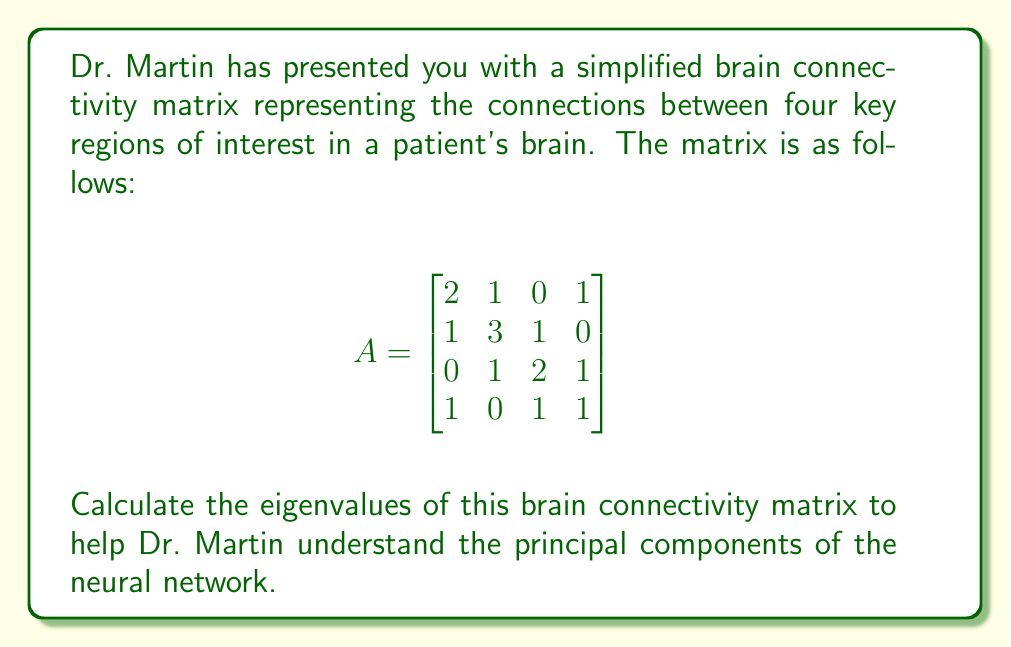What is the answer to this math problem? To find the eigenvalues of the matrix A, we need to solve the characteristic equation:

$$det(A - \lambda I) = 0$$

where $\lambda$ represents the eigenvalues and $I$ is the 4x4 identity matrix.

Step 1: Construct $(A - \lambda I)$
$$(A - \lambda I) = \begin{bmatrix}
2-\lambda & 1 & 0 & 1 \\
1 & 3-\lambda & 1 & 0 \\
0 & 1 & 2-\lambda & 1 \\
1 & 0 & 1 & 1-\lambda
\end{bmatrix}$$

Step 2: Calculate the determinant
$$det(A - \lambda I) = (2-\lambda)(3-\lambda)(2-\lambda)(1-\lambda) - (2-\lambda)(3-\lambda) - (2-\lambda)(1-\lambda) - (1-\lambda)$$

Step 3: Expand and simplify
$$\lambda^4 - 8\lambda^3 + 19\lambda^2 - 16\lambda + 4 = 0$$

Step 4: Solve the characteristic equation
This is a fourth-degree polynomial equation. While it's possible to solve it analytically using methods like Ferrari's solution, in practice, we often use numerical methods or computer algebra systems for higher-degree polynomials.

Using a numerical method, we find the roots of this polynomial:

$$\lambda_1 \approx 4.2915$$
$$\lambda_2 \approx 2.2728$$
$$\lambda_3 \approx 1.0000$$
$$\lambda_4 \approx 0.4357$$

These are the eigenvalues of the brain connectivity matrix.
Answer: The eigenvalues of the brain connectivity matrix are approximately:
$$\lambda_1 \approx 4.2915$$
$$\lambda_2 \approx 2.2728$$
$$\lambda_3 = 1.0000$$
$$\lambda_4 \approx 0.4357$$ 